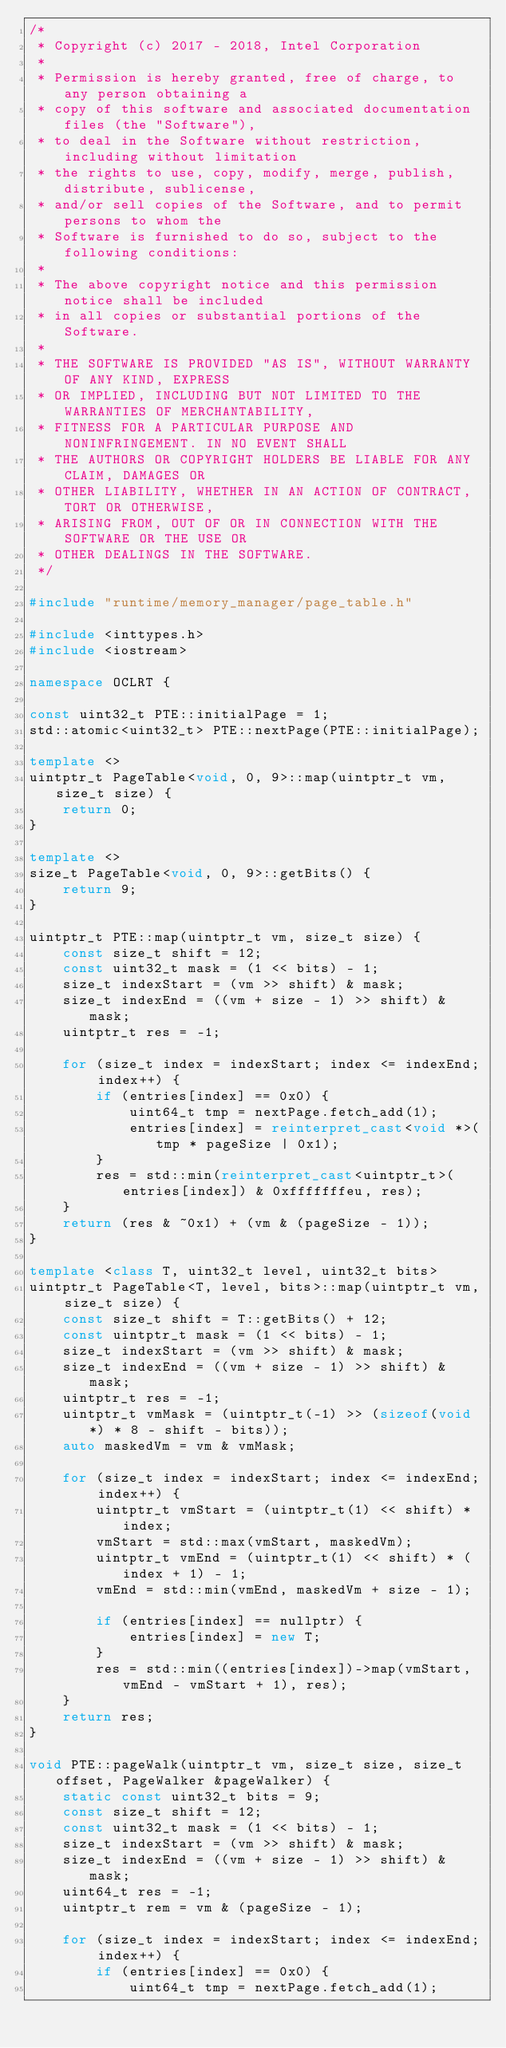Convert code to text. <code><loc_0><loc_0><loc_500><loc_500><_C++_>/*
 * Copyright (c) 2017 - 2018, Intel Corporation
 *
 * Permission is hereby granted, free of charge, to any person obtaining a
 * copy of this software and associated documentation files (the "Software"),
 * to deal in the Software without restriction, including without limitation
 * the rights to use, copy, modify, merge, publish, distribute, sublicense,
 * and/or sell copies of the Software, and to permit persons to whom the
 * Software is furnished to do so, subject to the following conditions:
 *
 * The above copyright notice and this permission notice shall be included
 * in all copies or substantial portions of the Software.
 *
 * THE SOFTWARE IS PROVIDED "AS IS", WITHOUT WARRANTY OF ANY KIND, EXPRESS
 * OR IMPLIED, INCLUDING BUT NOT LIMITED TO THE WARRANTIES OF MERCHANTABILITY,
 * FITNESS FOR A PARTICULAR PURPOSE AND NONINFRINGEMENT. IN NO EVENT SHALL
 * THE AUTHORS OR COPYRIGHT HOLDERS BE LIABLE FOR ANY CLAIM, DAMAGES OR
 * OTHER LIABILITY, WHETHER IN AN ACTION OF CONTRACT, TORT OR OTHERWISE,
 * ARISING FROM, OUT OF OR IN CONNECTION WITH THE SOFTWARE OR THE USE OR
 * OTHER DEALINGS IN THE SOFTWARE.
 */

#include "runtime/memory_manager/page_table.h"

#include <inttypes.h>
#include <iostream>

namespace OCLRT {

const uint32_t PTE::initialPage = 1;
std::atomic<uint32_t> PTE::nextPage(PTE::initialPage);

template <>
uintptr_t PageTable<void, 0, 9>::map(uintptr_t vm, size_t size) {
    return 0;
}

template <>
size_t PageTable<void, 0, 9>::getBits() {
    return 9;
}

uintptr_t PTE::map(uintptr_t vm, size_t size) {
    const size_t shift = 12;
    const uint32_t mask = (1 << bits) - 1;
    size_t indexStart = (vm >> shift) & mask;
    size_t indexEnd = ((vm + size - 1) >> shift) & mask;
    uintptr_t res = -1;

    for (size_t index = indexStart; index <= indexEnd; index++) {
        if (entries[index] == 0x0) {
            uint64_t tmp = nextPage.fetch_add(1);
            entries[index] = reinterpret_cast<void *>(tmp * pageSize | 0x1);
        }
        res = std::min(reinterpret_cast<uintptr_t>(entries[index]) & 0xfffffffeu, res);
    }
    return (res & ~0x1) + (vm & (pageSize - 1));
}

template <class T, uint32_t level, uint32_t bits>
uintptr_t PageTable<T, level, bits>::map(uintptr_t vm, size_t size) {
    const size_t shift = T::getBits() + 12;
    const uintptr_t mask = (1 << bits) - 1;
    size_t indexStart = (vm >> shift) & mask;
    size_t indexEnd = ((vm + size - 1) >> shift) & mask;
    uintptr_t res = -1;
    uintptr_t vmMask = (uintptr_t(-1) >> (sizeof(void *) * 8 - shift - bits));
    auto maskedVm = vm & vmMask;

    for (size_t index = indexStart; index <= indexEnd; index++) {
        uintptr_t vmStart = (uintptr_t(1) << shift) * index;
        vmStart = std::max(vmStart, maskedVm);
        uintptr_t vmEnd = (uintptr_t(1) << shift) * (index + 1) - 1;
        vmEnd = std::min(vmEnd, maskedVm + size - 1);

        if (entries[index] == nullptr) {
            entries[index] = new T;
        }
        res = std::min((entries[index])->map(vmStart, vmEnd - vmStart + 1), res);
    }
    return res;
}

void PTE::pageWalk(uintptr_t vm, size_t size, size_t offset, PageWalker &pageWalker) {
    static const uint32_t bits = 9;
    const size_t shift = 12;
    const uint32_t mask = (1 << bits) - 1;
    size_t indexStart = (vm >> shift) & mask;
    size_t indexEnd = ((vm + size - 1) >> shift) & mask;
    uint64_t res = -1;
    uintptr_t rem = vm & (pageSize - 1);

    for (size_t index = indexStart; index <= indexEnd; index++) {
        if (entries[index] == 0x0) {
            uint64_t tmp = nextPage.fetch_add(1);</code> 